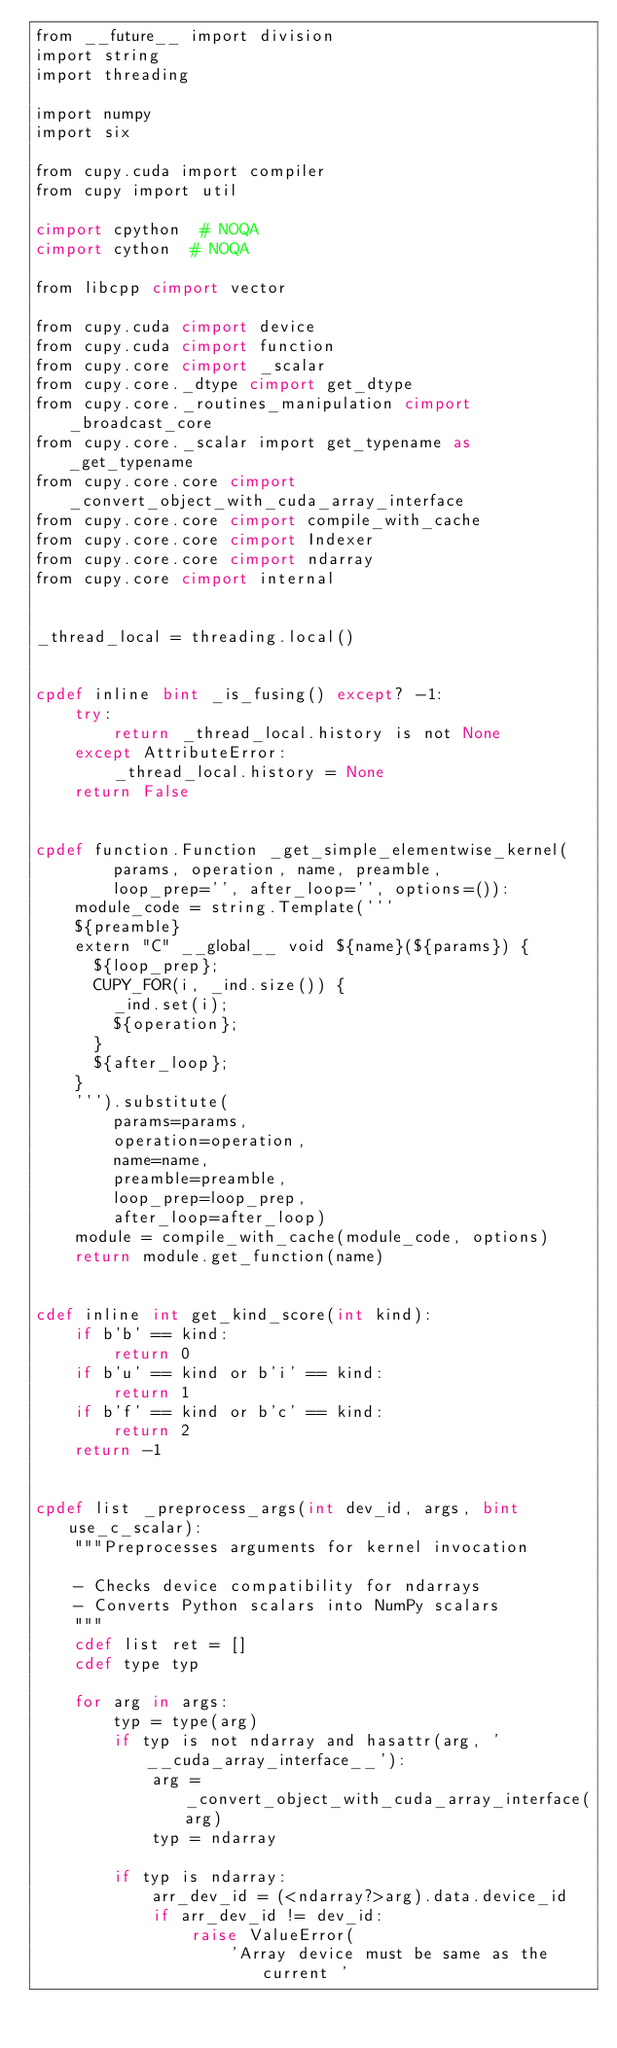<code> <loc_0><loc_0><loc_500><loc_500><_Cython_>from __future__ import division
import string
import threading

import numpy
import six

from cupy.cuda import compiler
from cupy import util

cimport cpython  # NOQA
cimport cython  # NOQA

from libcpp cimport vector

from cupy.cuda cimport device
from cupy.cuda cimport function
from cupy.core cimport _scalar
from cupy.core._dtype cimport get_dtype
from cupy.core._routines_manipulation cimport _broadcast_core
from cupy.core._scalar import get_typename as _get_typename
from cupy.core.core cimport _convert_object_with_cuda_array_interface
from cupy.core.core cimport compile_with_cache
from cupy.core.core cimport Indexer
from cupy.core.core cimport ndarray
from cupy.core cimport internal


_thread_local = threading.local()


cpdef inline bint _is_fusing() except? -1:
    try:
        return _thread_local.history is not None
    except AttributeError:
        _thread_local.history = None
    return False


cpdef function.Function _get_simple_elementwise_kernel(
        params, operation, name, preamble,
        loop_prep='', after_loop='', options=()):
    module_code = string.Template('''
    ${preamble}
    extern "C" __global__ void ${name}(${params}) {
      ${loop_prep};
      CUPY_FOR(i, _ind.size()) {
        _ind.set(i);
        ${operation};
      }
      ${after_loop};
    }
    ''').substitute(
        params=params,
        operation=operation,
        name=name,
        preamble=preamble,
        loop_prep=loop_prep,
        after_loop=after_loop)
    module = compile_with_cache(module_code, options)
    return module.get_function(name)


cdef inline int get_kind_score(int kind):
    if b'b' == kind:
        return 0
    if b'u' == kind or b'i' == kind:
        return 1
    if b'f' == kind or b'c' == kind:
        return 2
    return -1


cpdef list _preprocess_args(int dev_id, args, bint use_c_scalar):
    """Preprocesses arguments for kernel invocation

    - Checks device compatibility for ndarrays
    - Converts Python scalars into NumPy scalars
    """
    cdef list ret = []
    cdef type typ

    for arg in args:
        typ = type(arg)
        if typ is not ndarray and hasattr(arg, '__cuda_array_interface__'):
            arg = _convert_object_with_cuda_array_interface(arg)
            typ = ndarray

        if typ is ndarray:
            arr_dev_id = (<ndarray?>arg).data.device_id
            if arr_dev_id != dev_id:
                raise ValueError(
                    'Array device must be same as the current '</code> 